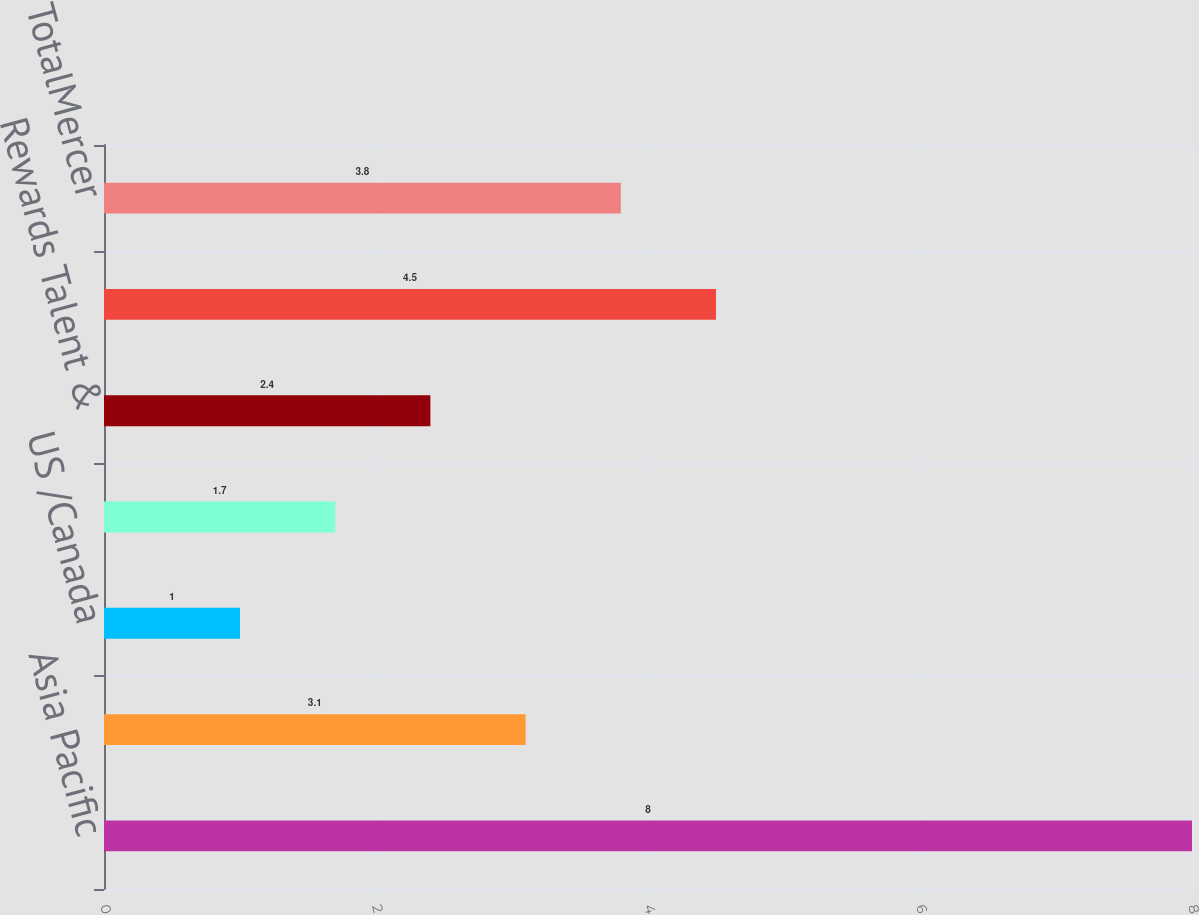Convert chart. <chart><loc_0><loc_0><loc_500><loc_500><bar_chart><fcel>Asia Pacific<fcel>TotalInternational<fcel>US /Canada<fcel>TotalMarsh<fcel>Rewards Talent &<fcel>Outsourcing<fcel>TotalMercer<nl><fcel>8<fcel>3.1<fcel>1<fcel>1.7<fcel>2.4<fcel>4.5<fcel>3.8<nl></chart> 